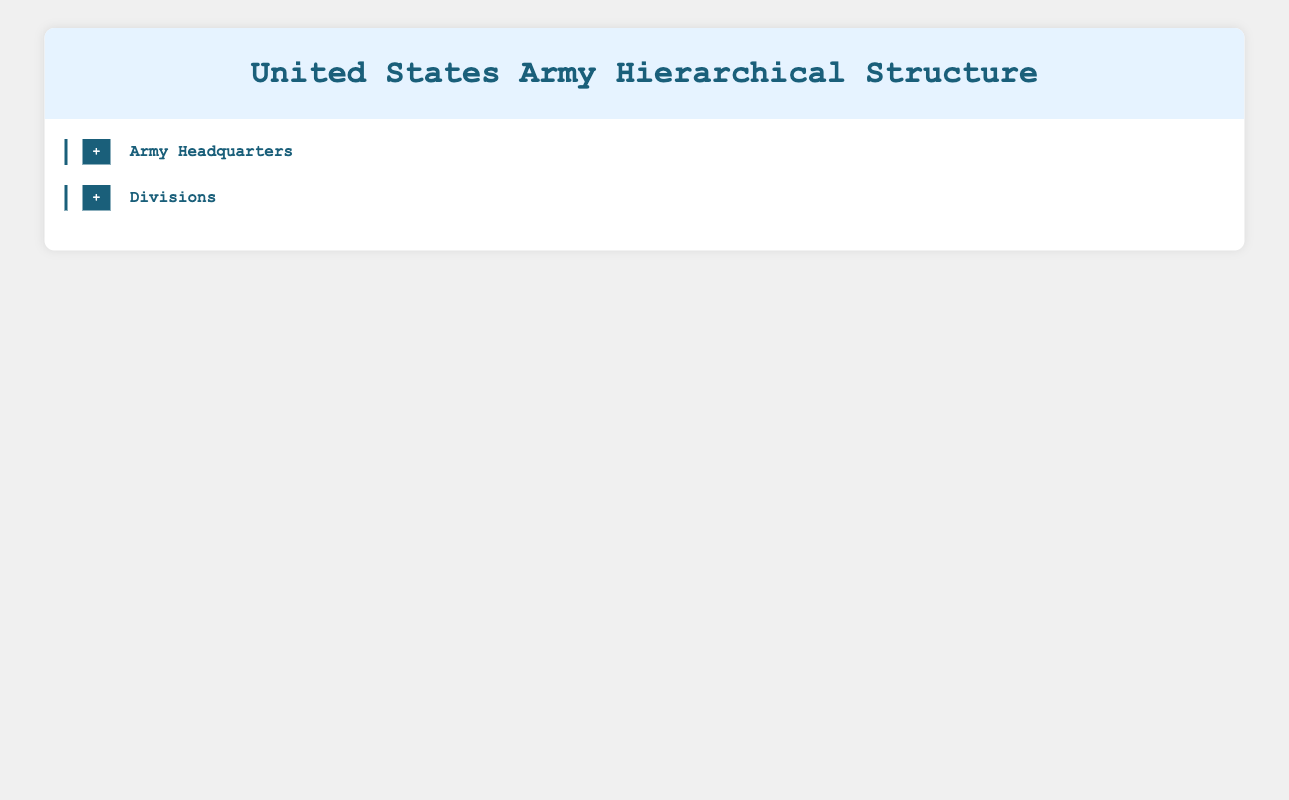What is the name of the Chief of Staff in the United States Army? The table states that the Chief of Staff is General James C. McConville. This information is directly mentioned under the Army Headquarters section.
Answer: General James C. McConville How many HR Specialists are in the G-1 (Personnel) unit? According to the table, the G-1 (Personnel) unit, led by Major General Scott E. Miller, has 50 HR Specialists listed in the personnel section.
Answer: 50 What is the total number of personnel in the Alpha and Bravo Companies combined? The table shows that Alpha Company has 150 personnel and Bravo Company also has 150 personnel. Summing these numbers gives 150 + 150 = 300 personnel.
Answer: 300 Is the Brigade Commander of the 1st Infantry Division a Major General? The table indicates that the Brigade Commander of the 1st Infantry Division, Colonel John Smith, holds the rank of Colonel and not Major General. Therefore, the statement is false.
Answer: No Which unit has the highest number of total personnel listed in the table? The table indicates that both the Alpha Company and Bravo Company have 150 personnel each, and similarly, Charlie Company and Delta Company also have 150 personnel each. Since all these companies have the same number of personnel, there is no single unit that has the highest personnel. Therefore, we can say that multiple companies share the highest total of 150 personnel.
Answer: All companies listed have equal personnel of 150 Who commands the 3rd Brigade Combat Team? The table states that the 3rd Brigade Combat Team is commanded by Colonel Robert Lee. This information is clearly provided under the 101st Airborne Division section.
Answer: Colonel Robert Lee How many plans officers are mentioned in the G-3 (Operations) unit? From the table, it is specified that the G-3 (Operations) unit has 12 Plans Officers as part of its personnel. This is stated directly in the information pertaining to Major General Christopher A. Cavoli.
Answer: 12 What is the total number of all HR Specialists and Recruiters in the G-1 (Personnel) unit? The table lists 50 HR Specialists and 25 Recruiters in the G-1 (Personnel) unit. To find the total, we add these two numbers: 50 + 25 = 75 personnel.
Answer: 75 Which division is commanded by Major General D. Scott McKean? The table clearly states that the 1st Infantry Division is commanded by Major General D. Scott McKean, which is directly mentioned under that division's section.
Answer: 1st Infantry Division 